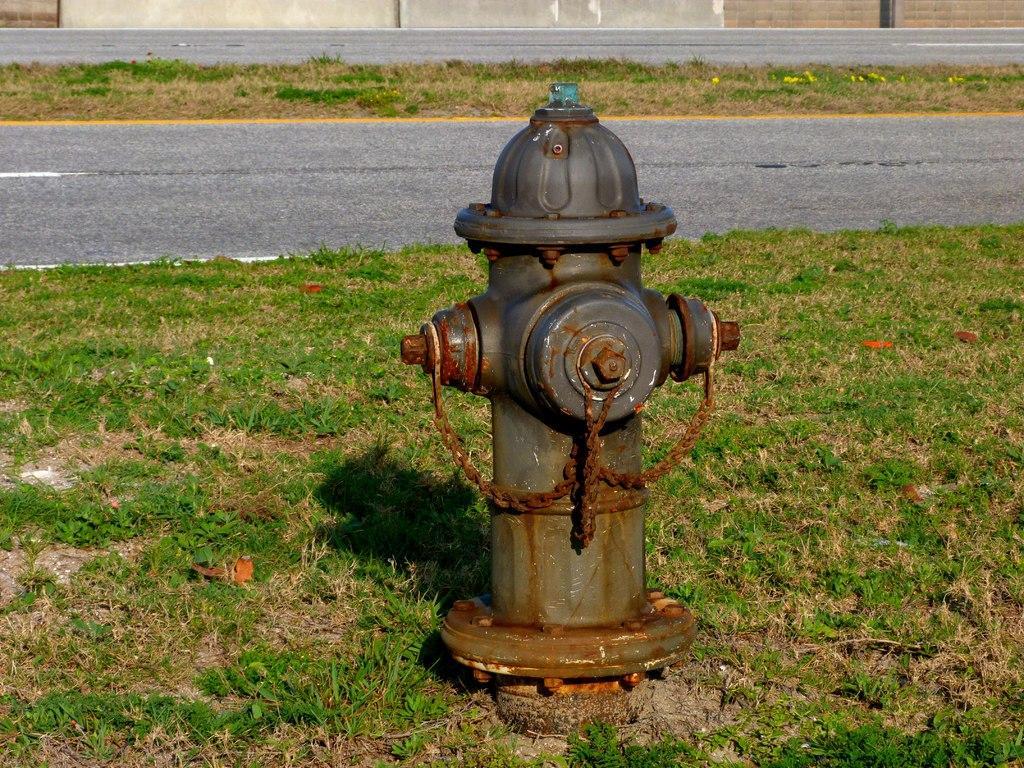Please provide a concise description of this image. In this image we can see a fire hydrant. Around the fire hydrant we can see the grass. In the background, we can see the grass, road and a wall. 